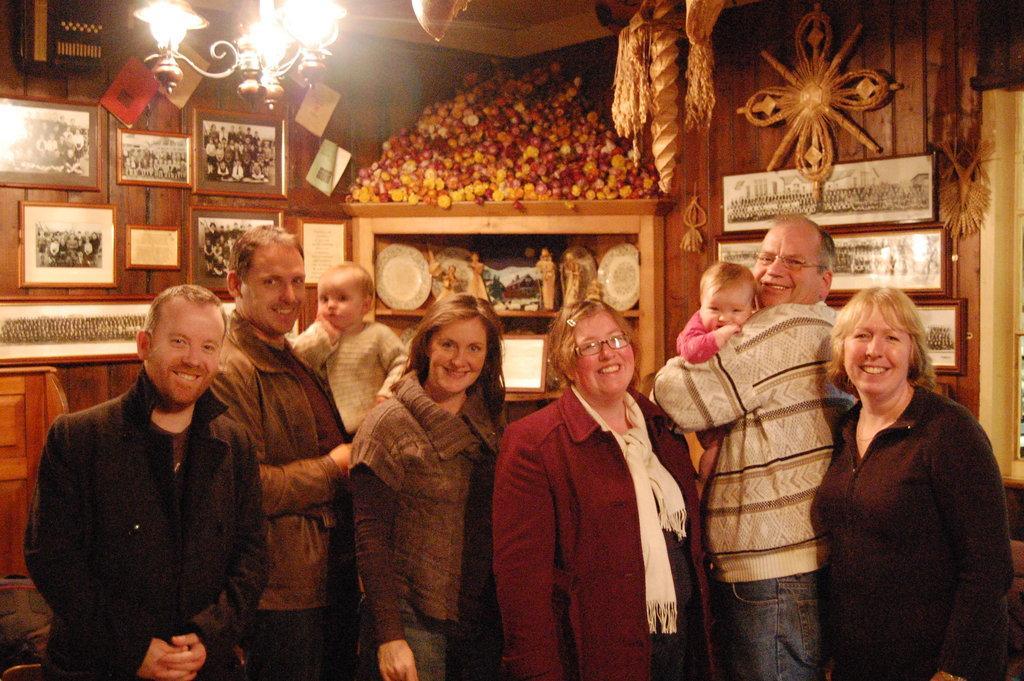How would you summarize this image in a sentence or two? In this picture there is a woman who is wearing jacket, t-shirt and jeans. Beside her there is another woman who is wearing a red jacket, scarf, t-shirt, trouser and spectacle. On the right there is another woman who is wearing black dress. Beside her there is a man who is holding a baby. On the left there is a man who is wearing jacket and t-shirt. He is standing near to the man who is holding a boy. Everyone is smiling. In the back i can see the statues, plates, mirror and other objects on the wooden shelf. Beside that i can see many photo frames and posters on the wall. At the top i can see the chandelier which is hanging from the roof of the building. On the right background there is a window. 